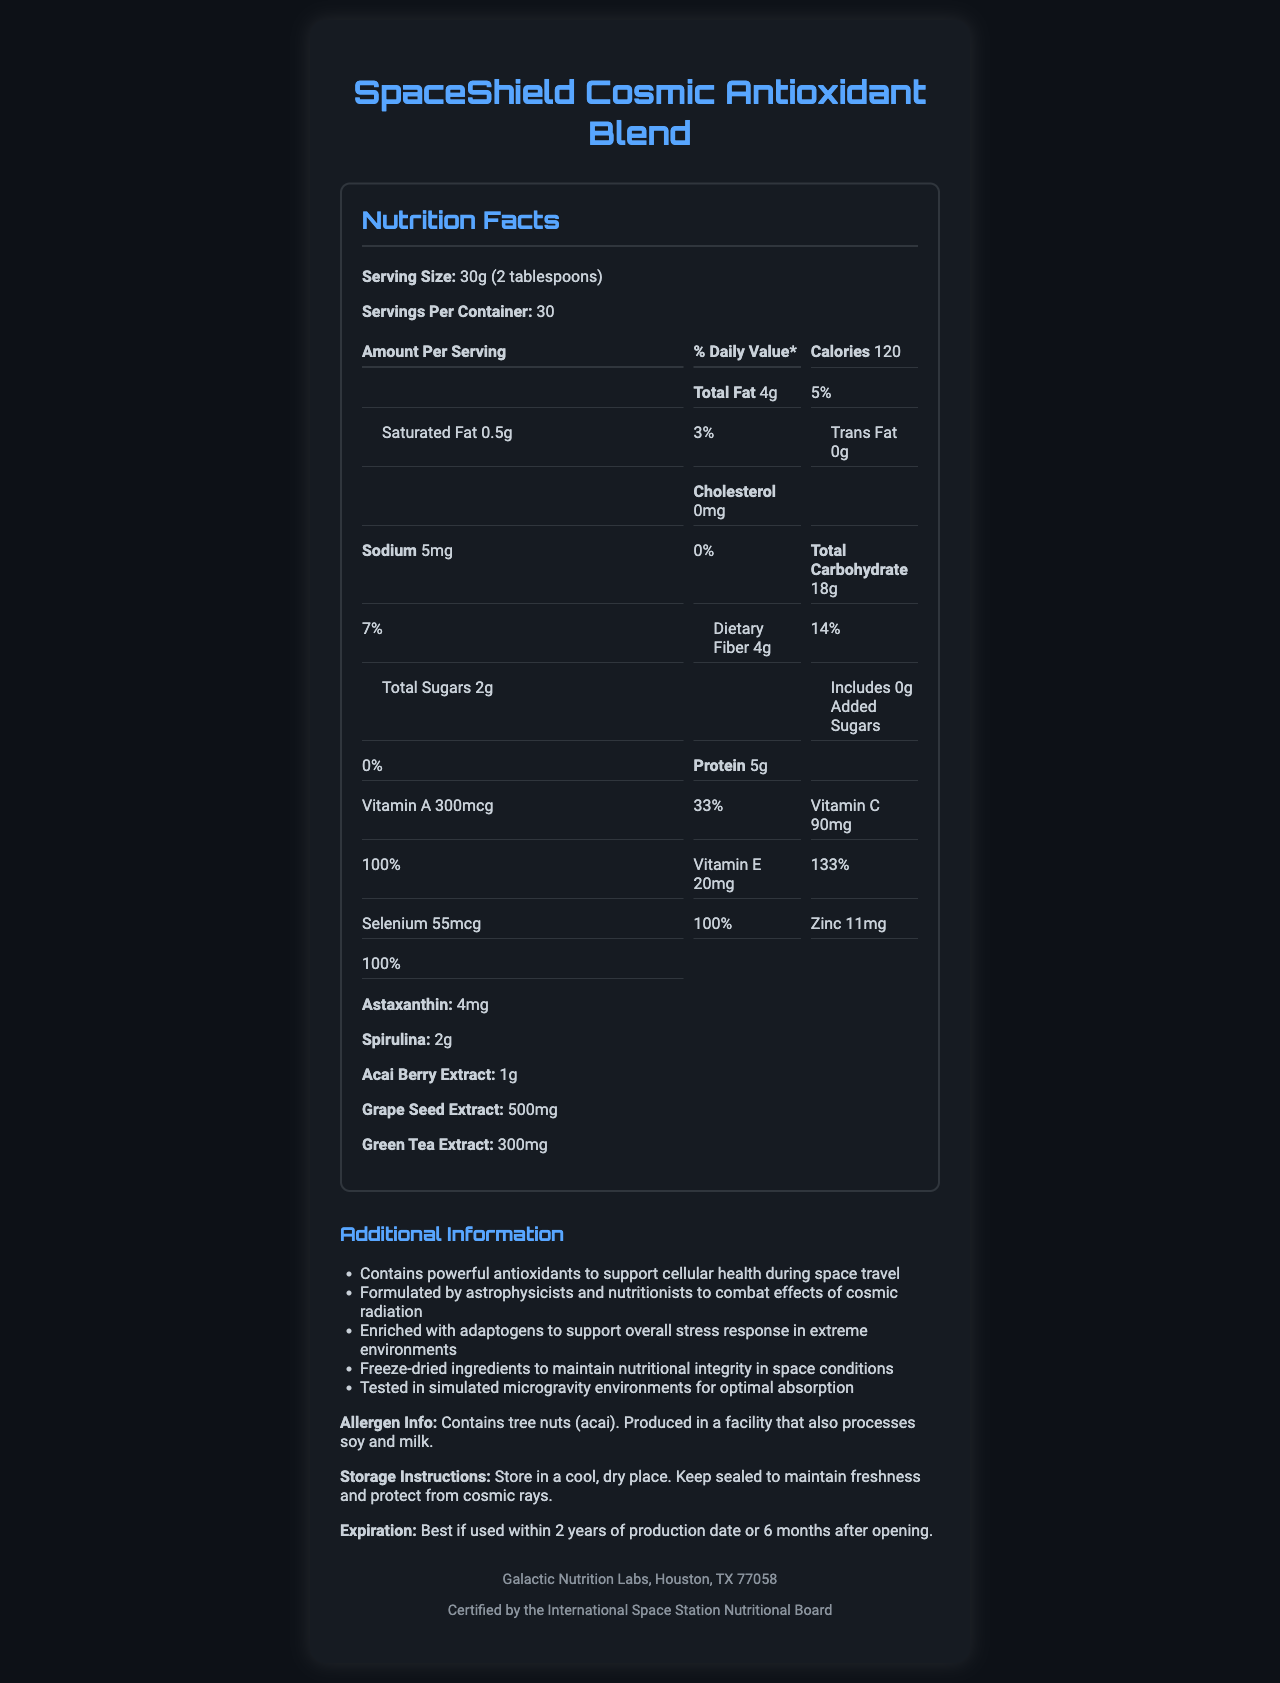what is the serving size of the SpaceShield Cosmic Antioxidant Blend? The document specifies the serving size is 30g, which is equivalent to 2 tablespoons.
Answer: 30g (2 tablespoons) how many servings are there per container? The document states there are 30 servings per container.
Answer: 30 how many calories are in one serving? According to the document, each serving contains 120 calories.
Answer: 120 what is the total fat content per serving? The document shows that the product contains 4g of total fat per serving.
Answer: 4g what is the daily value percentage of Vitamin E per serving? The document lists the daily value percentage of Vitamin E as 133%.
Answer: 133% what is the amount of protein in one serving? The document indicates there are 5g of protein per serving.
Answer: 5g how much dietary fiber is in each serving? The document states that each serving contains 4g of dietary fiber.
Answer: 4g what is the total carbohydrate content in one serving? A. 14g B. 18g C. 20g D. 22g The document lists the total carbohydrate content per serving as 18g.
Answer: B. 18g which of the following is NOT an ingredient in the SpaceShield Cosmic Antioxidant Blend? I. Astaxanthin II. Spirulina III. Whey Protein The document lists astaxanthin and spirulina but does not mention whey protein.
Answer: III. Whey Protein are there any added sugars in the product? The document clearly states that there are 0g of added sugars and 0% daily value.
Answer: No does the product contain any tree nuts? The allergen information in the document mentions that the product contains tree nuts (acai).
Answer: Yes what are the storage instructions for the product? The document provides these storage instructions to maintain the product's integrity.
Answer: Store in a cool, dry place. Keep sealed to maintain freshness and protect from cosmic rays. is the document certified by any specific organization? The document mentions this certification in the footer.
Answer: Yes, certified by the International Space Station Nutritional Board can the specific effects of grape seed extract be determined from the document? The document states that it contains grape seed extract but does not specify the effects.
Answer: Not enough information what is the main idea of this document? The document outlines the serving size, nutritional content, additional ingredients, allergen info, storage instructions, certification, and manufacturer details.
Answer: The document provides detailed nutritional information about SpaceShield Cosmic Antioxidant Blend, highlighting its ingredients, health benefits, and usage guidelines. does the product have any cholesterol content? The document states that the product contains 0mg of cholesterol.
Answer: No what is the level of sodium in each serving? The document specifies that each serving contains 5mg of sodium.
Answer: 5mg what percentage of daily value for Vitamin C does one serving provide? The document lists the daily value percentage for Vitamin C as 100%.
Answer: 100% 